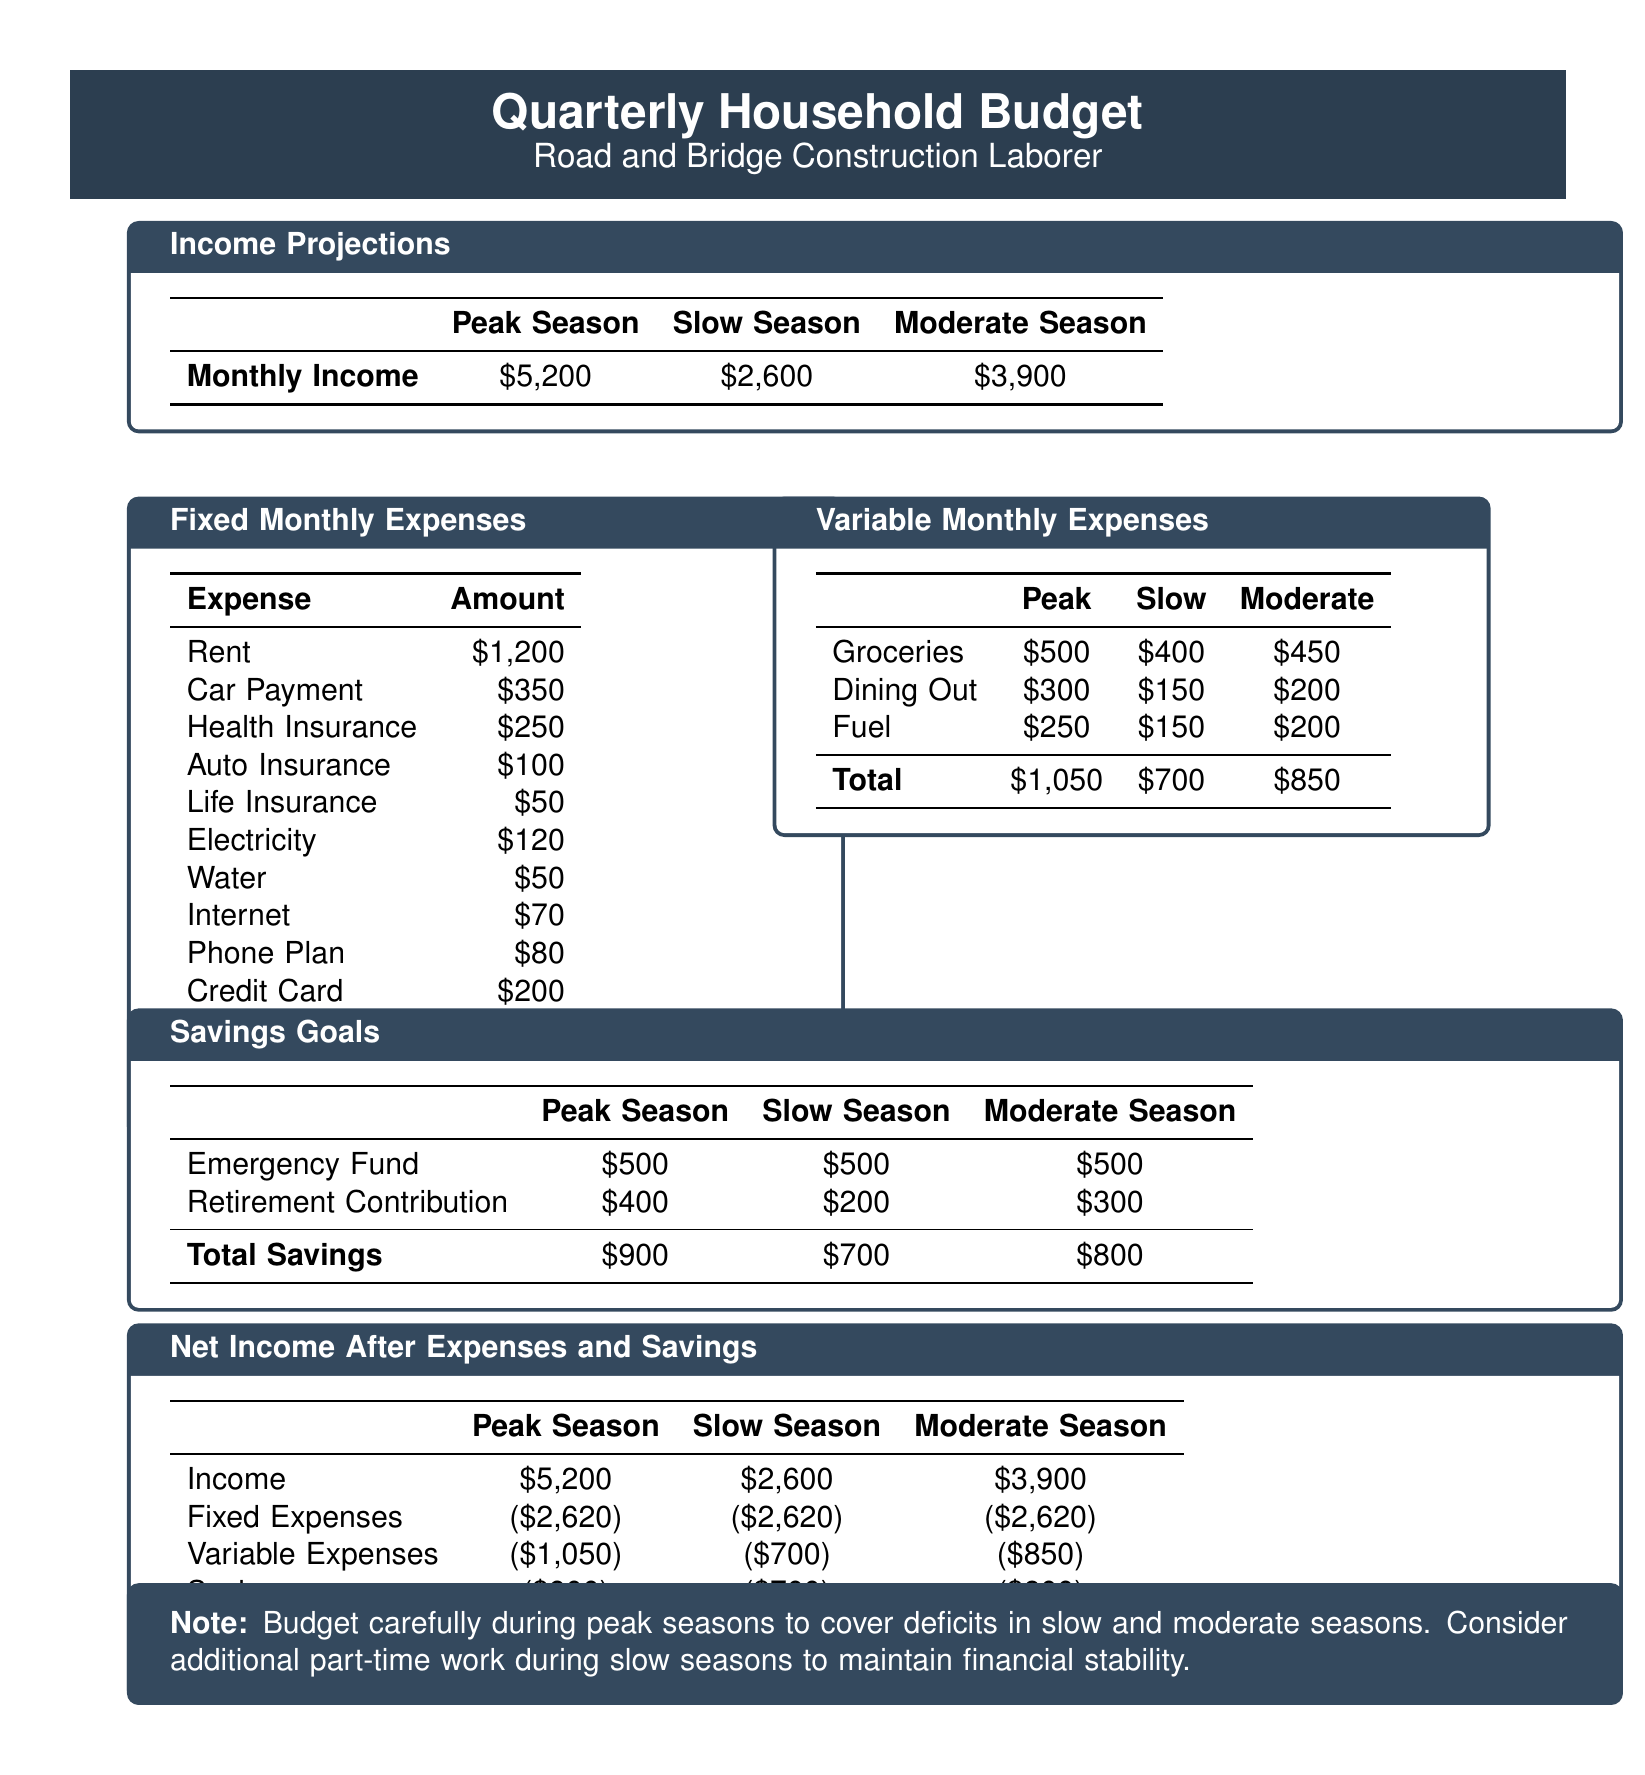What is the monthly income during peak season? The monthly income during the peak season is explicitly stated in the document.
Answer: $5,200 What are the total fixed monthly expenses? The total fixed monthly expenses are calculated in the fixed expenses section of the document.
Answer: $2,620 How much is allocated for groceries during slow season? The document provides specific amounts for groceries in each season.
Answer: $400 What is the total savings during moderate season? The document summarizes the total savings for moderate season at the end of the savings goals section.
Answer: $800 What is the net income after expenses and savings in slow season? The document shows the net income for slow season after subtracting expenses and savings.
Answer: ($1,420) How much is deducted for health insurance? The fixed monthly expenses section lists health insurance as one of the expenses.
Answer: $250 What should be noted regarding budgeting during peak seasons? The document provides a note emphasizing the importance of careful budgeting in peak seasons.
Answer: Budget carefully during peak seasons to cover deficits in slow and moderate seasons What is the total variable expenses in peak season? The total variable expenses for peak season are summarized at the end of the variable expenses section.
Answer: $1,050 How much is the retirement contribution during slow season? The document lists the retirement contribution under savings goals for each season.
Answer: $200 